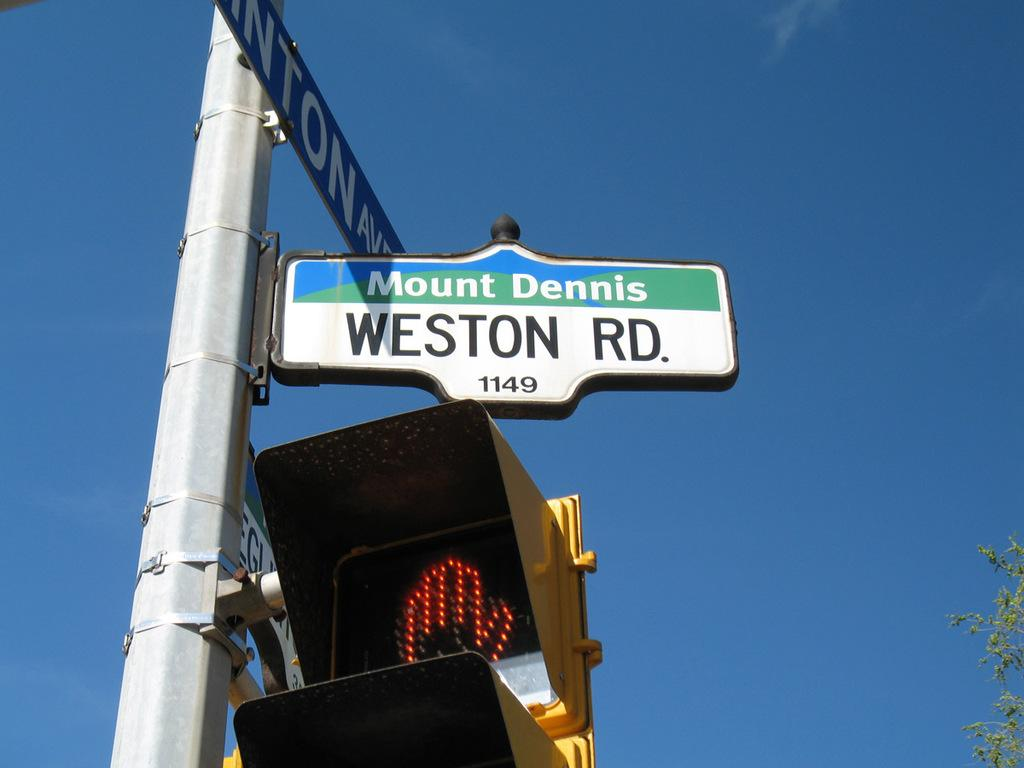<image>
Give a short and clear explanation of the subsequent image. The street sign at 1149 weston road on a clear day. 